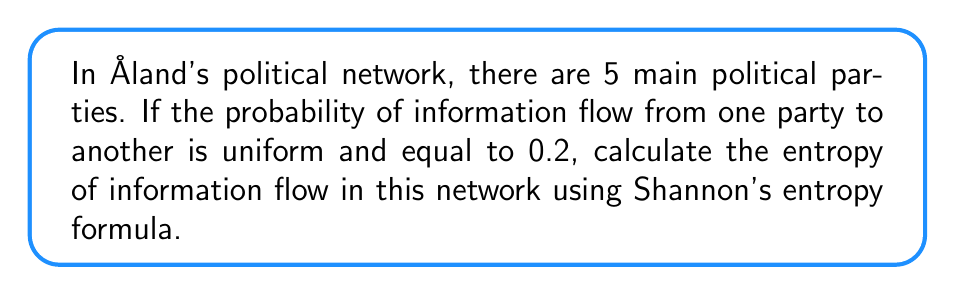Help me with this question. To solve this problem, we'll use Shannon's entropy formula:

$$H = -\sum_{i=1}^{n} p_i \log_2(p_i)$$

Where:
$H$ is the entropy
$n$ is the number of possible outcomes
$p_i$ is the probability of each outcome

Step 1: Identify the given information
- Number of political parties: $n = 5$
- Probability of information flow between any two parties: $p = 0.2$

Step 2: Apply Shannon's entropy formula
$$H = -\sum_{i=1}^{5} 0.2 \log_2(0.2)$$

Step 3: Simplify the equation
$$H = -5 \cdot 0.2 \log_2(0.2)$$

Step 4: Calculate $\log_2(0.2)$
$\log_2(0.2) \approx -2.3219$

Step 5: Substitute and calculate the final result
$$H = -5 \cdot 0.2 \cdot (-2.3219) = 2.3219$$

Therefore, the entropy of information flow in Åland's political network is approximately 2.3219 bits.
Answer: 2.3219 bits 